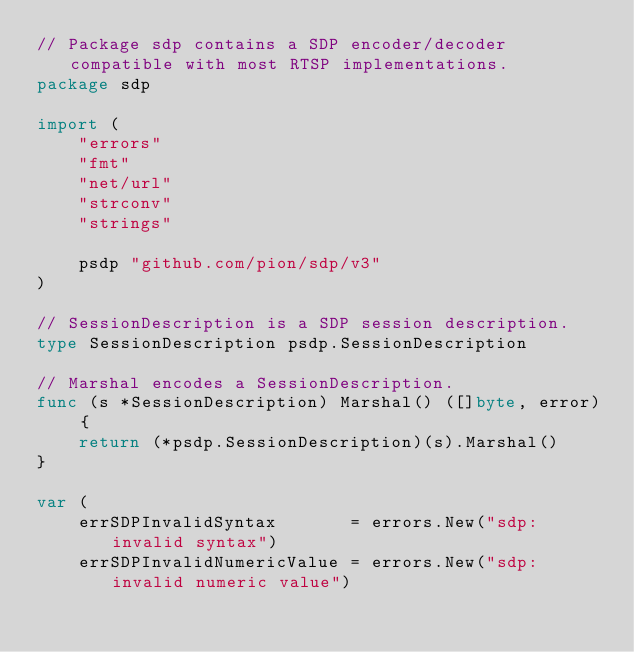<code> <loc_0><loc_0><loc_500><loc_500><_Go_>// Package sdp contains a SDP encoder/decoder compatible with most RTSP implementations.
package sdp

import (
	"errors"
	"fmt"
	"net/url"
	"strconv"
	"strings"

	psdp "github.com/pion/sdp/v3"
)

// SessionDescription is a SDP session description.
type SessionDescription psdp.SessionDescription

// Marshal encodes a SessionDescription.
func (s *SessionDescription) Marshal() ([]byte, error) {
	return (*psdp.SessionDescription)(s).Marshal()
}

var (
	errSDPInvalidSyntax       = errors.New("sdp: invalid syntax")
	errSDPInvalidNumericValue = errors.New("sdp: invalid numeric value")</code> 